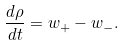Convert formula to latex. <formula><loc_0><loc_0><loc_500><loc_500>\frac { d \rho } { d t } = w _ { + } - w _ { - } .</formula> 